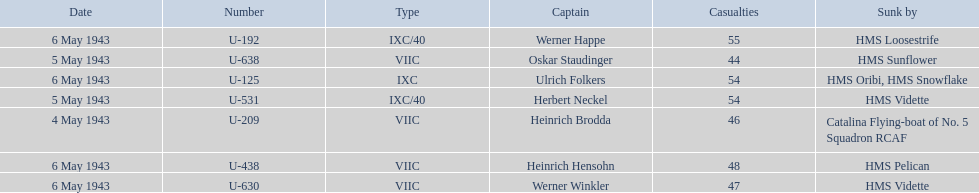What boats were lost on may 5? U-638, U-531. Who were the captains of those boats? Oskar Staudinger, Herbert Neckel. Which captain was not oskar staudinger? Herbert Neckel. Can you give me this table in json format? {'header': ['Date', 'Number', 'Type', 'Captain', 'Casualties', 'Sunk by'], 'rows': [['6 May 1943', 'U-192', 'IXC/40', 'Werner Happe', '55', 'HMS Loosestrife'], ['5 May 1943', 'U-638', 'VIIC', 'Oskar Staudinger', '44', 'HMS Sunflower'], ['6 May 1943', 'U-125', 'IXC', 'Ulrich Folkers', '54', 'HMS Oribi, HMS Snowflake'], ['5 May 1943', 'U-531', 'IXC/40', 'Herbert Neckel', '54', 'HMS Vidette'], ['4 May 1943', 'U-209', 'VIIC', 'Heinrich Brodda', '46', 'Catalina Flying-boat of No. 5 Squadron RCAF'], ['6 May 1943', 'U-438', 'VIIC', 'Heinrich Hensohn', '48', 'HMS Pelican'], ['6 May 1943', 'U-630', 'VIIC', 'Werner Winkler', '47', 'HMS Vidette']]} 